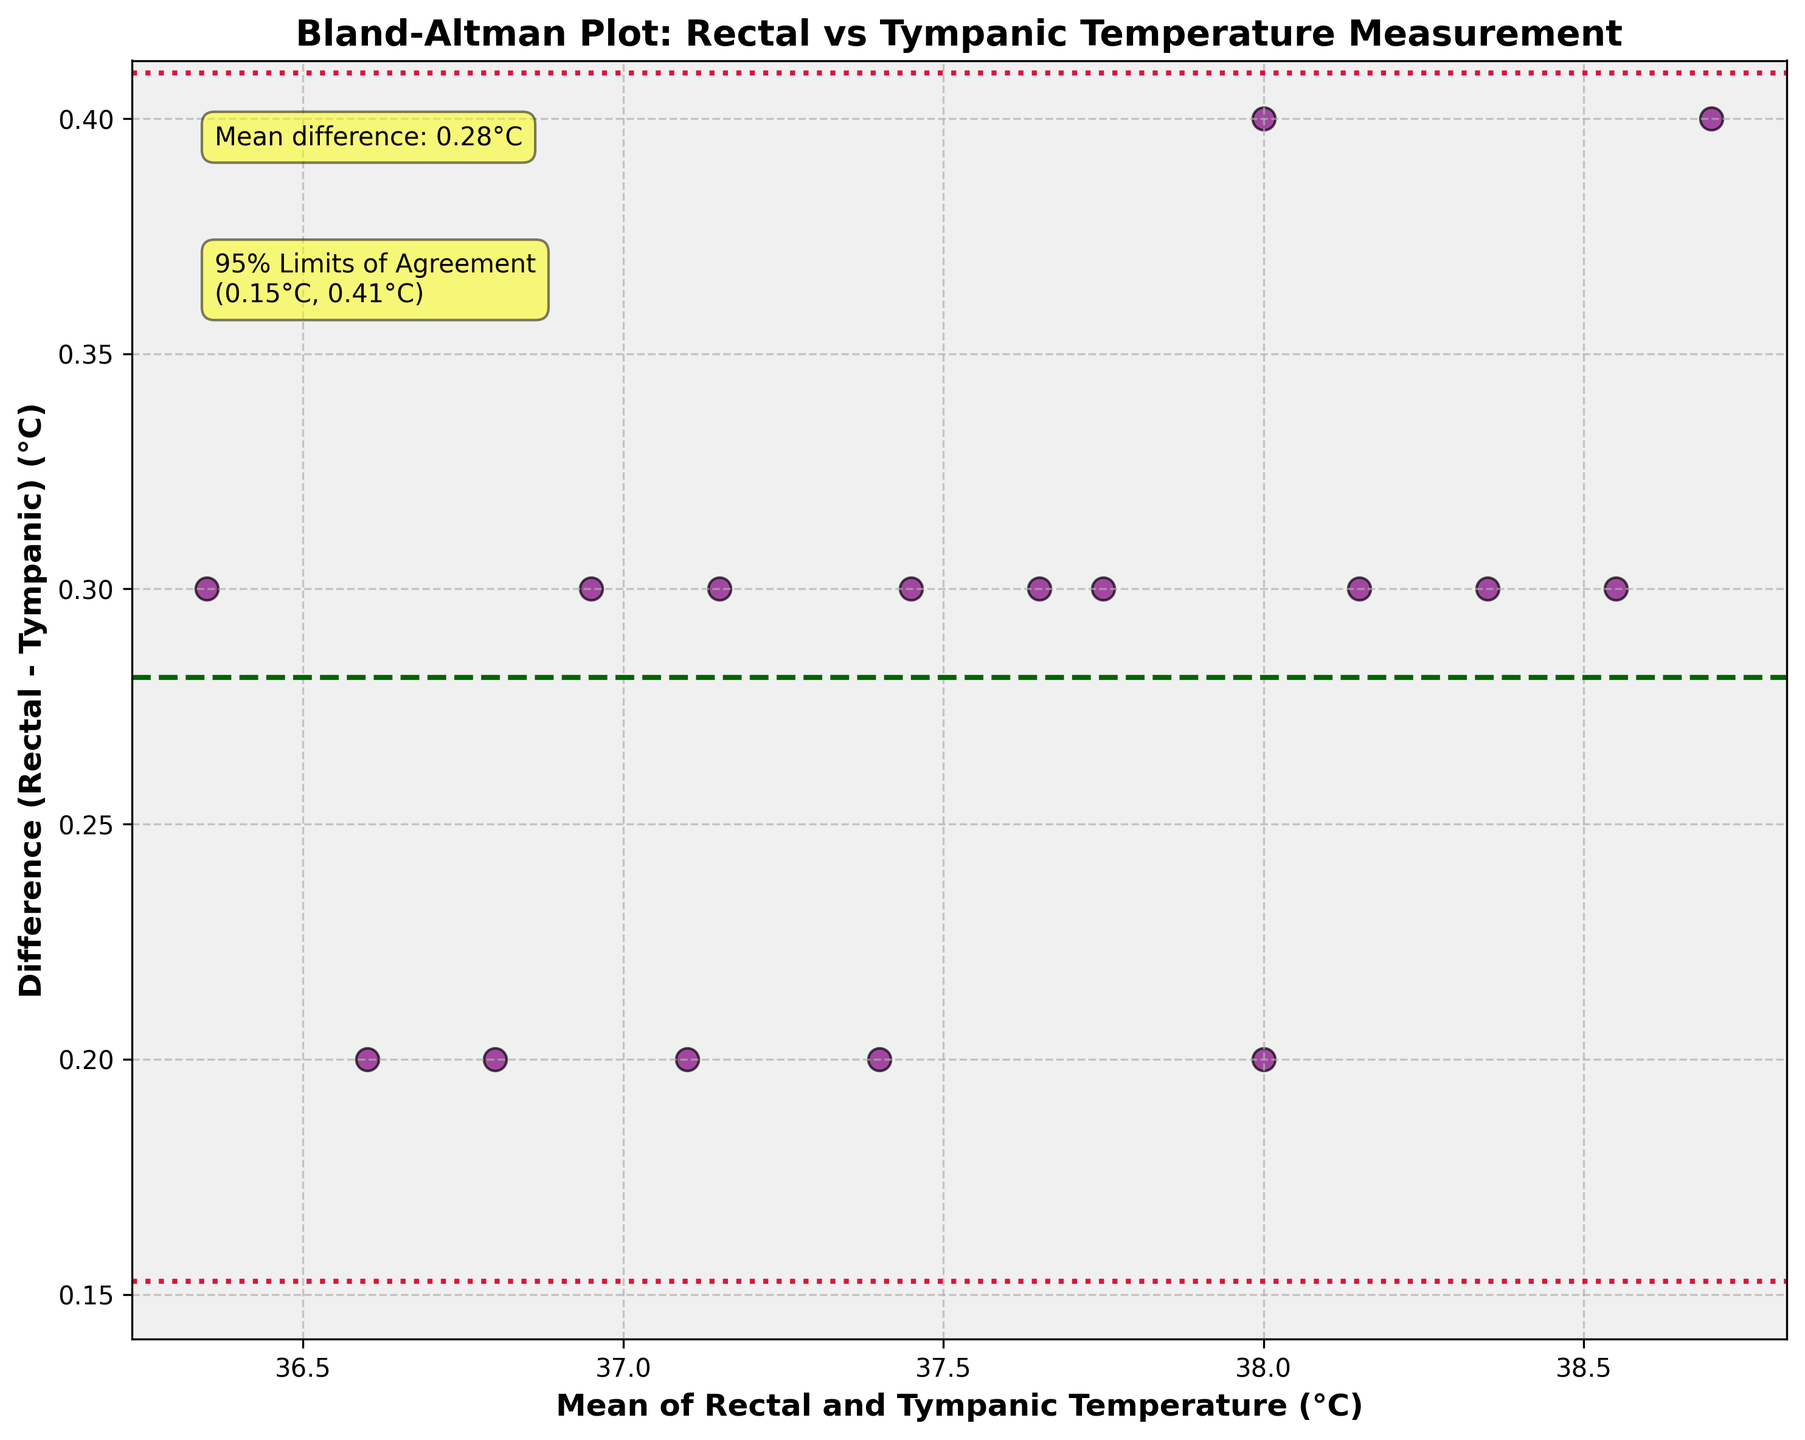What does the plot represent? The title of the plot states "Bland-Altman Plot: Rectal vs Tympanic Temperature Measurement". This indicates that the plot is used to compare the agreement between rectal and tympanic methods of measuring body temperature in pediatric patients using Bland-Altman analysis.
Answer: Agreement between rectal and tympanic temperature measurements What are the axes labels on the plot? The x-axis is labeled "Mean of Rectal and Tympanic Temperature (°C)" and the y-axis is labeled "Difference (Rectal - Tympanic) (°C)". These labels indicate what each axis represents in the plot.
Answer: Mean temperature (x-axis), Difference in temperature (y-axis) What is the mean temperature difference shown in the plot? The plot has an annotation stating "Mean difference: 0.26°C". Additionally, a horizontal dashed line in dark green at 0.26°C represents the mean difference between rectal and tympanic measurements.
Answer: 0.26°C What do the red dotted lines in the plot represent? The red dotted lines mark the 95% limits of agreement. The annotations in the plot mention "95% Limits of Agreement\n(-0.05°C, 0.57°C)". These lines indicate the range within which 95% of the differences between rectal and tympanic measurements are expected to fall.
Answer: 95% limits of agreement How many data points are plotted? By counting the number of purple markers (data points) on the plot, we can see that there are 16 data points.
Answer: 16 Are there any outliers in the plot? Outliers would be data points that fall outside the red dotted lines representing the 95% limits of agreement. Here, all data points are within the limits, so there are no outliers.
Answer: No Which temperature method tends to measure higher, rectal or tympanic? The plot shows a mostly positive difference (values above the zero line on the y-axis), meaning that rectal temperatures tend to be higher than tympanic temperatures.
Answer: Rectal What is the standard deviation of the temperature differences? The plot does not explicitly state the standard deviation. However, knowing the mean difference (0.26°C) and the 95% limits of agreement (-0.05°C, 0.57°C), the standard deviation can be calculated as (upper limit - mean) / 1.96.
Answer: 0.16°C What is the most recurring mean temperature range in the data? The majority of the data points are clustered around the mean temperature range of approximately 37°C to 38°C, as seen on the x-axis.
Answer: 37°C to 38°C 